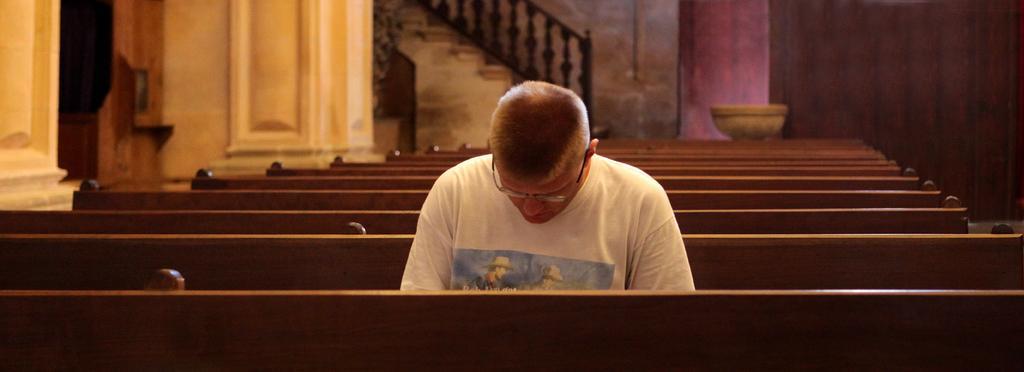Can you describe this image briefly? In the picture I can see a person wearing white color T-shirt sitting on a bench, there are some benches and in the background there is a wall and staircase. 